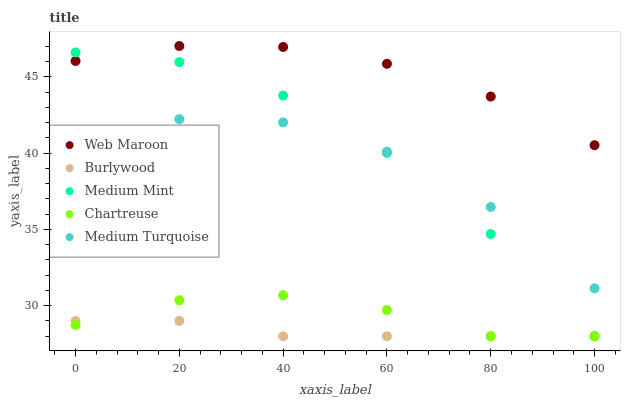Does Burlywood have the minimum area under the curve?
Answer yes or no. Yes. Does Web Maroon have the maximum area under the curve?
Answer yes or no. Yes. Does Medium Mint have the minimum area under the curve?
Answer yes or no. No. Does Medium Mint have the maximum area under the curve?
Answer yes or no. No. Is Burlywood the smoothest?
Answer yes or no. Yes. Is Medium Turquoise the roughest?
Answer yes or no. Yes. Is Medium Mint the smoothest?
Answer yes or no. No. Is Medium Mint the roughest?
Answer yes or no. No. Does Burlywood have the lowest value?
Answer yes or no. Yes. Does Web Maroon have the lowest value?
Answer yes or no. No. Does Web Maroon have the highest value?
Answer yes or no. Yes. Does Medium Mint have the highest value?
Answer yes or no. No. Is Burlywood less than Medium Turquoise?
Answer yes or no. Yes. Is Web Maroon greater than Chartreuse?
Answer yes or no. Yes. Does Burlywood intersect Medium Mint?
Answer yes or no. Yes. Is Burlywood less than Medium Mint?
Answer yes or no. No. Is Burlywood greater than Medium Mint?
Answer yes or no. No. Does Burlywood intersect Medium Turquoise?
Answer yes or no. No. 